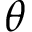<formula> <loc_0><loc_0><loc_500><loc_500>\theta</formula> 